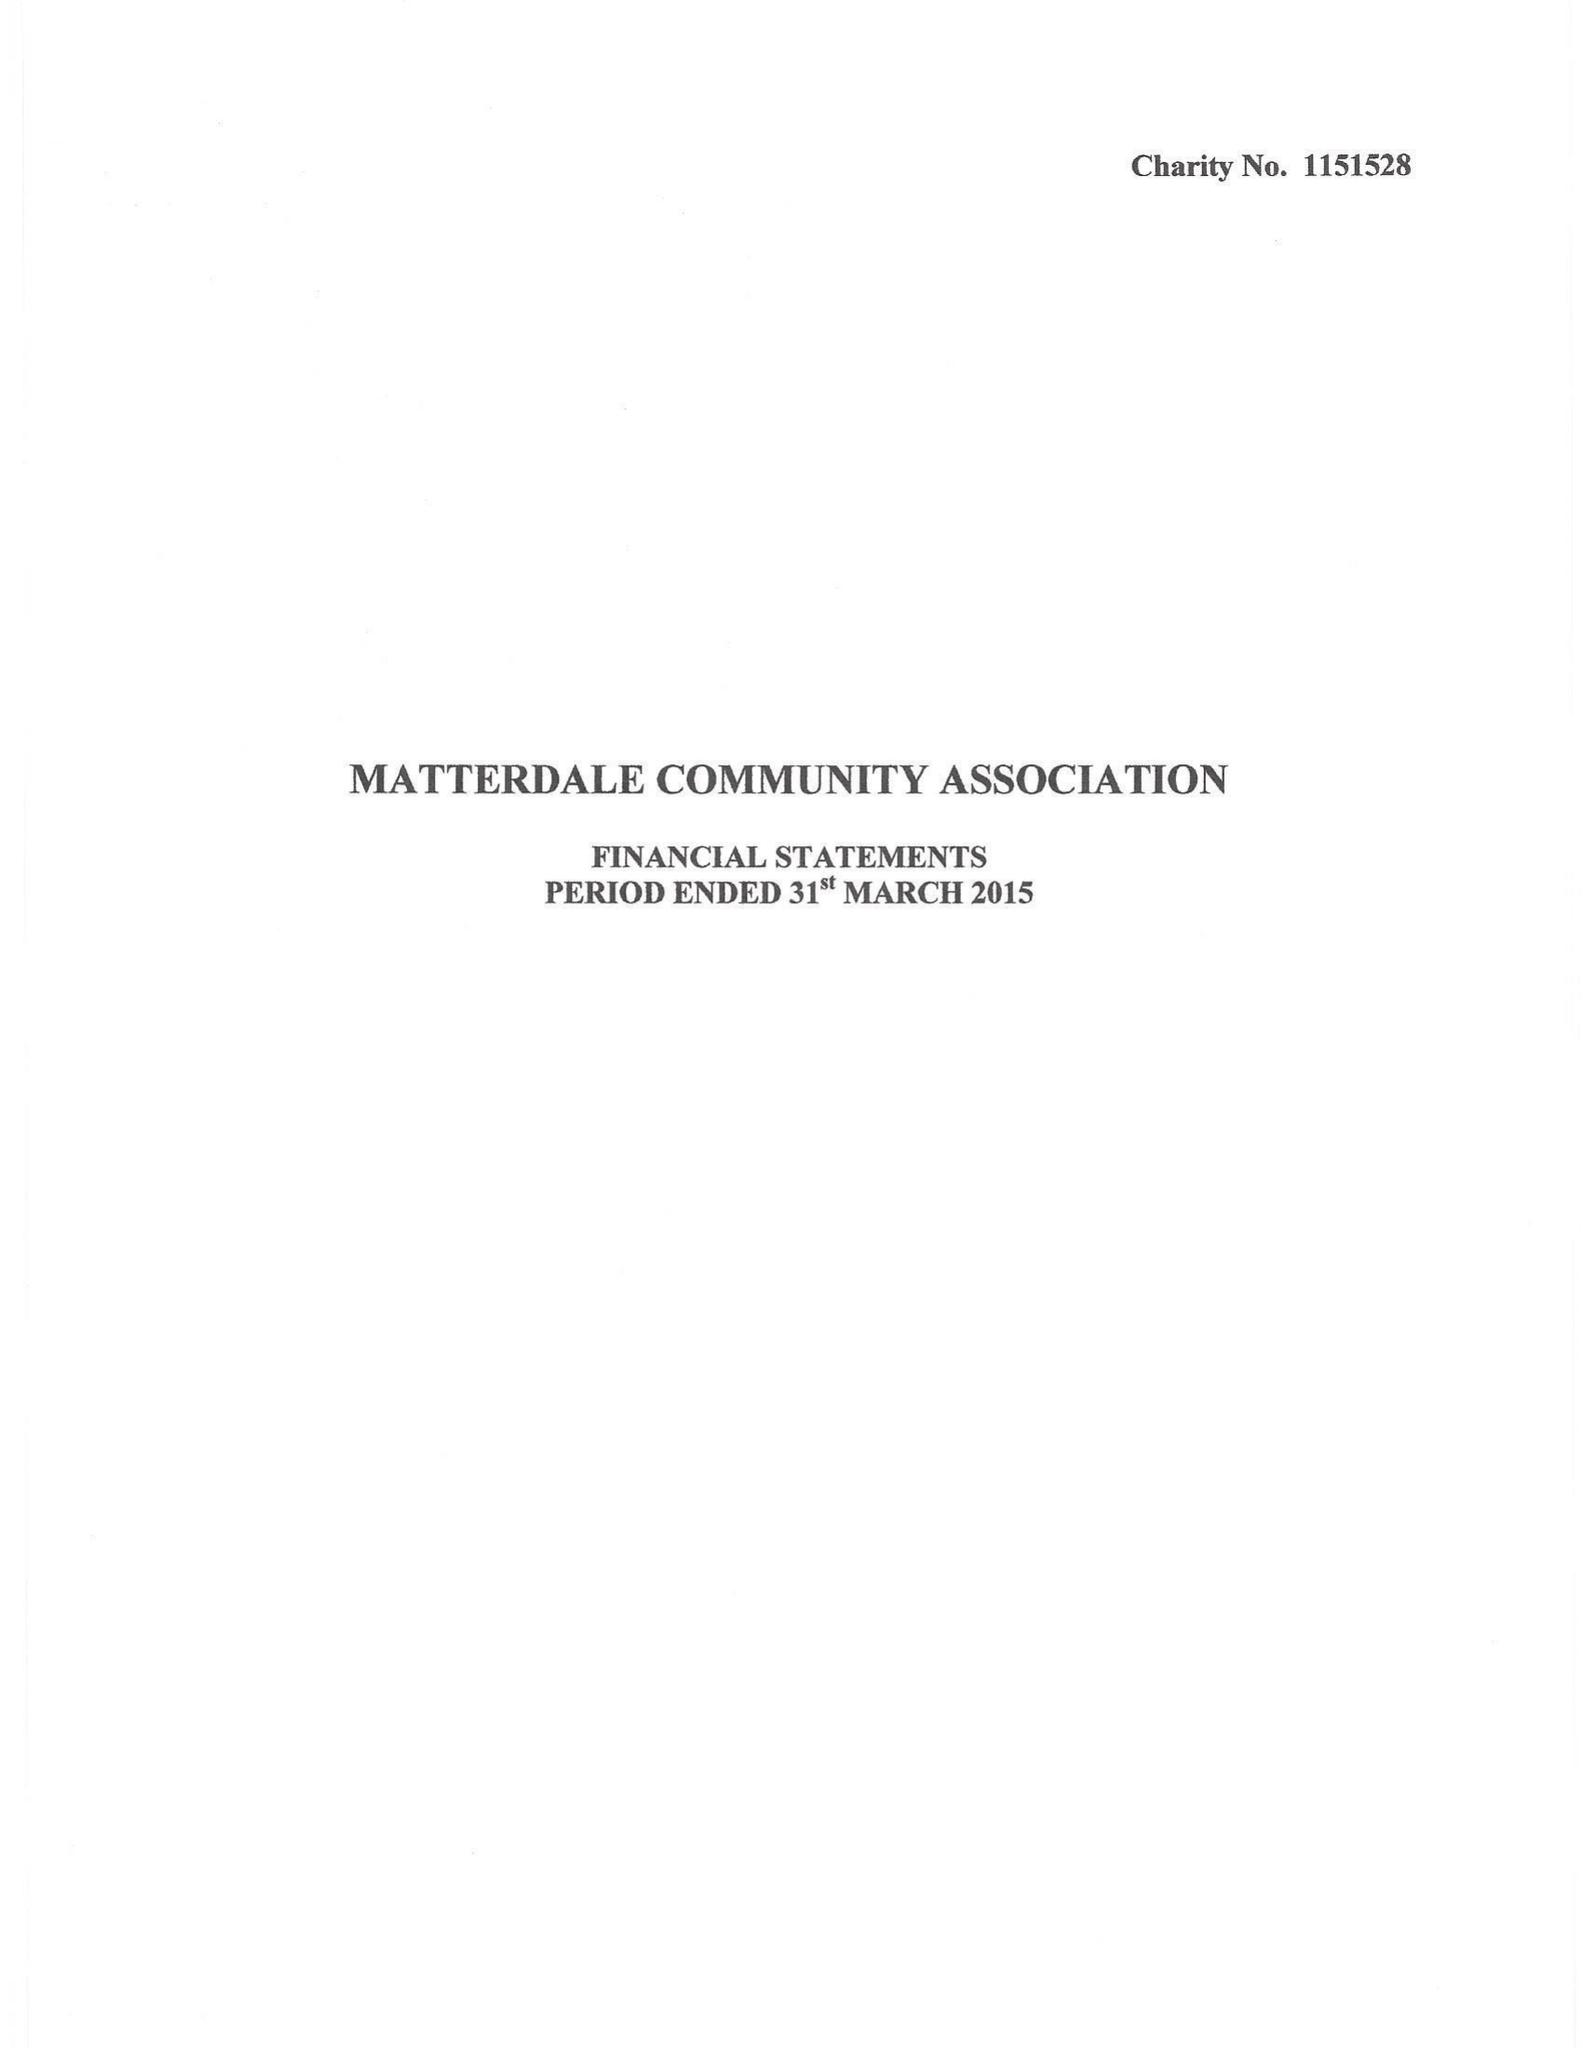What is the value for the charity_number?
Answer the question using a single word or phrase. 1151528 